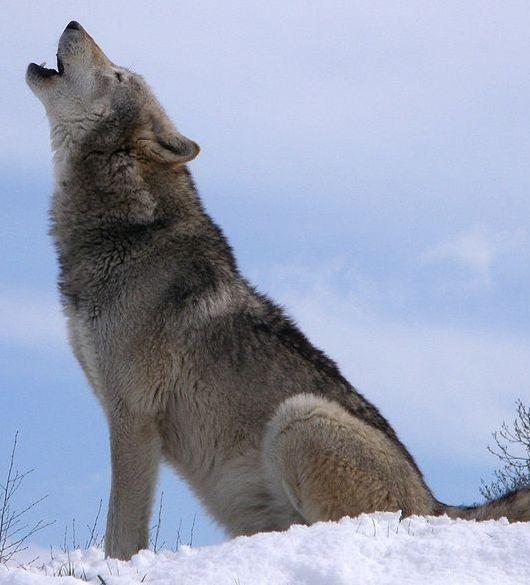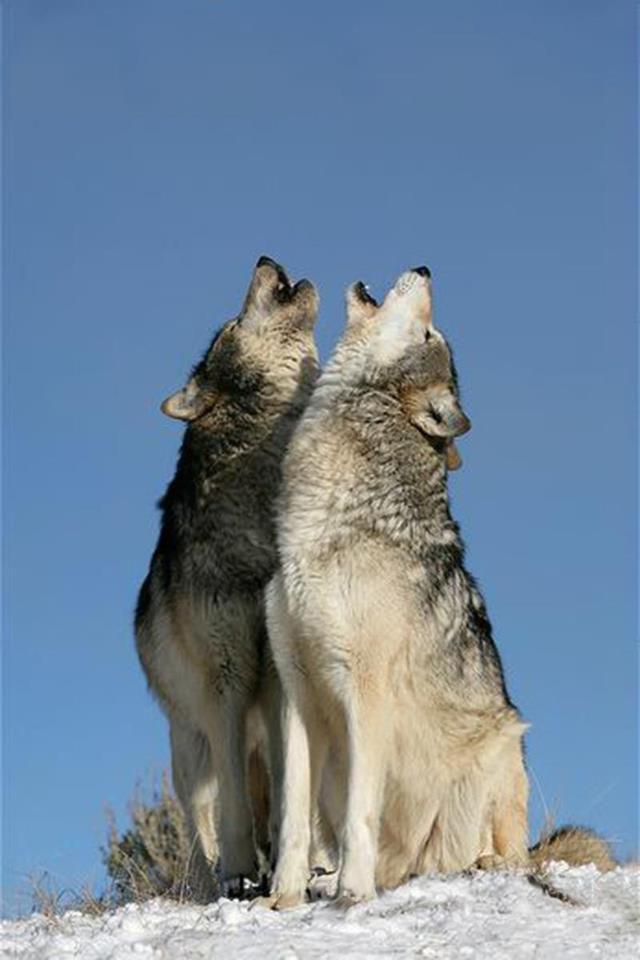The first image is the image on the left, the second image is the image on the right. For the images displayed, is the sentence "Four howling wolves are shown against dark and stormy skies." factually correct? Answer yes or no. No. The first image is the image on the left, the second image is the image on the right. Analyze the images presented: Is the assertion "Each image shows exactly one howling wolf." valid? Answer yes or no. No. 